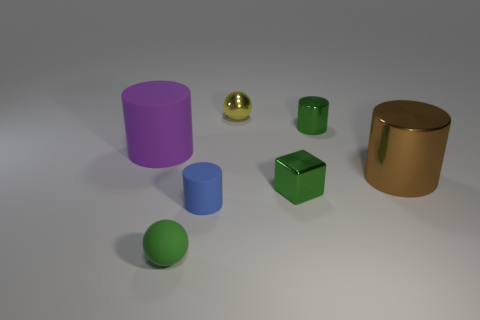Subtract all purple cylinders. How many cylinders are left? 3 Add 1 gray metallic balls. How many objects exist? 8 Subtract all red cylinders. Subtract all red cubes. How many cylinders are left? 4 Subtract all cubes. How many objects are left? 6 Add 6 big rubber cylinders. How many big rubber cylinders exist? 7 Subtract 0 yellow cylinders. How many objects are left? 7 Subtract all big rubber cylinders. Subtract all tiny yellow metallic spheres. How many objects are left? 5 Add 4 shiny blocks. How many shiny blocks are left? 5 